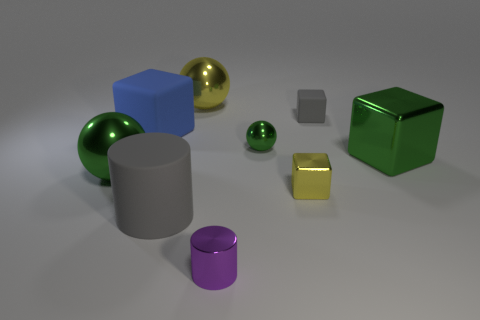Add 1 large purple metal things. How many objects exist? 10 Subtract all blocks. How many objects are left? 5 Add 9 tiny blue things. How many tiny blue things exist? 9 Subtract 1 gray cylinders. How many objects are left? 8 Subtract all small yellow rubber balls. Subtract all tiny purple metallic cylinders. How many objects are left? 8 Add 9 purple metal cylinders. How many purple metal cylinders are left? 10 